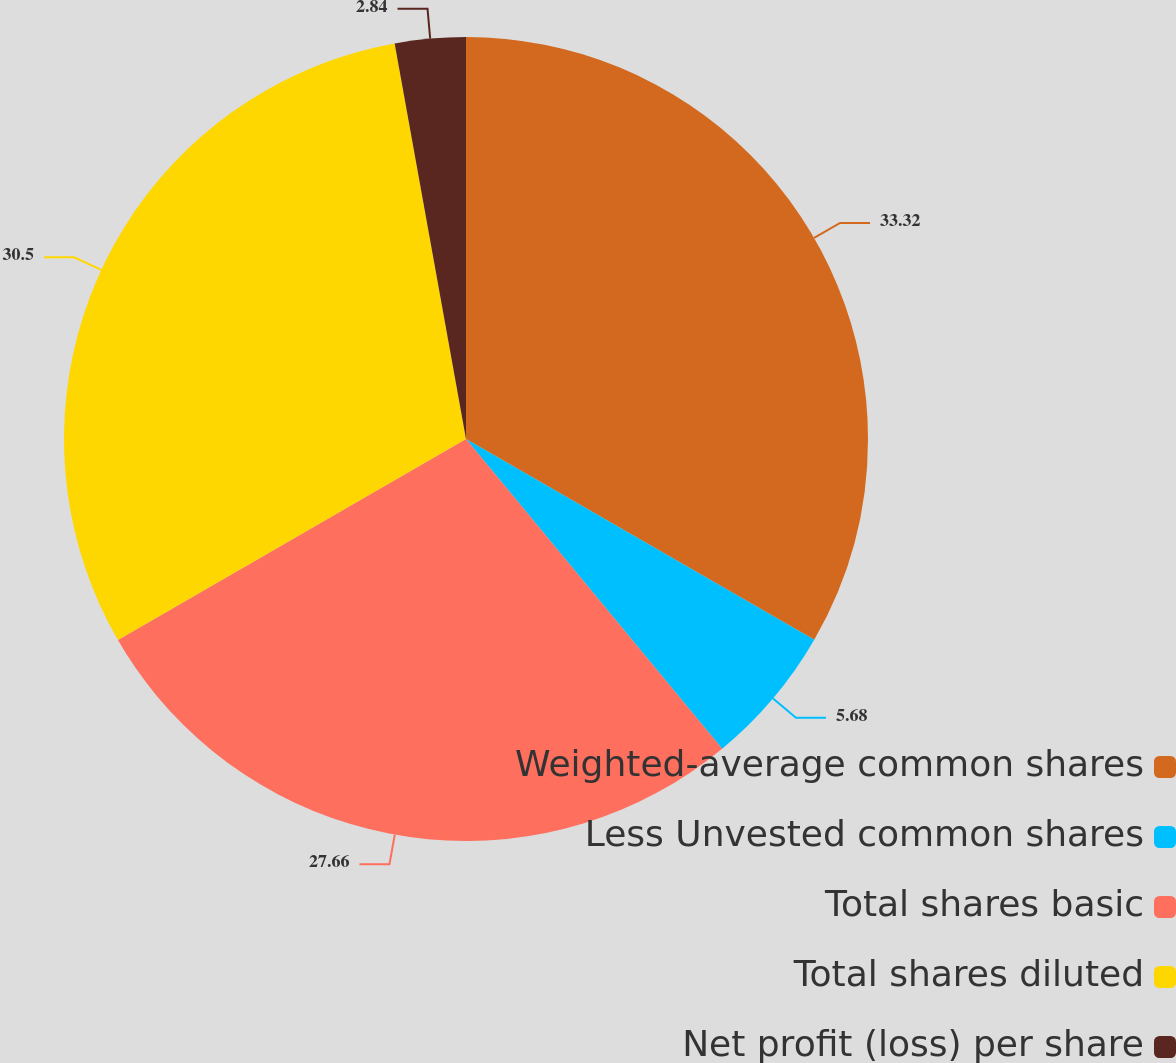<chart> <loc_0><loc_0><loc_500><loc_500><pie_chart><fcel>Weighted-average common shares<fcel>Less Unvested common shares<fcel>Total shares basic<fcel>Total shares diluted<fcel>Net profit (loss) per share<nl><fcel>33.33%<fcel>5.68%<fcel>27.66%<fcel>30.5%<fcel>2.84%<nl></chart> 